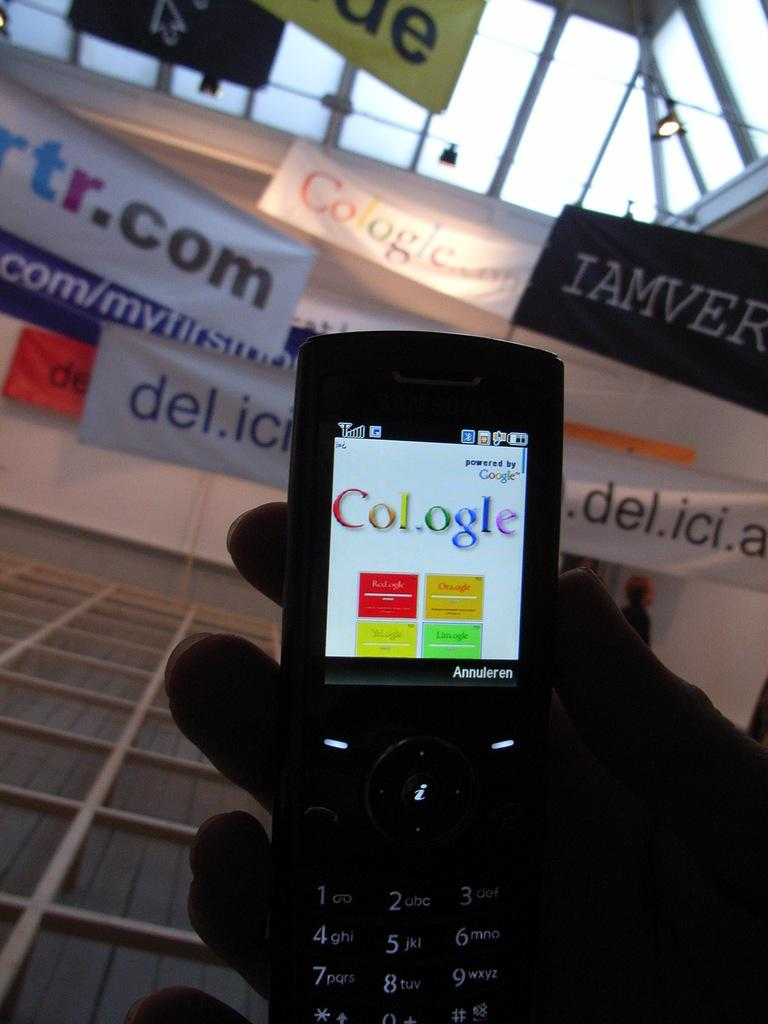<image>
Provide a brief description of the given image. A cell phone that says Annuleren and has a fake google page on it. 